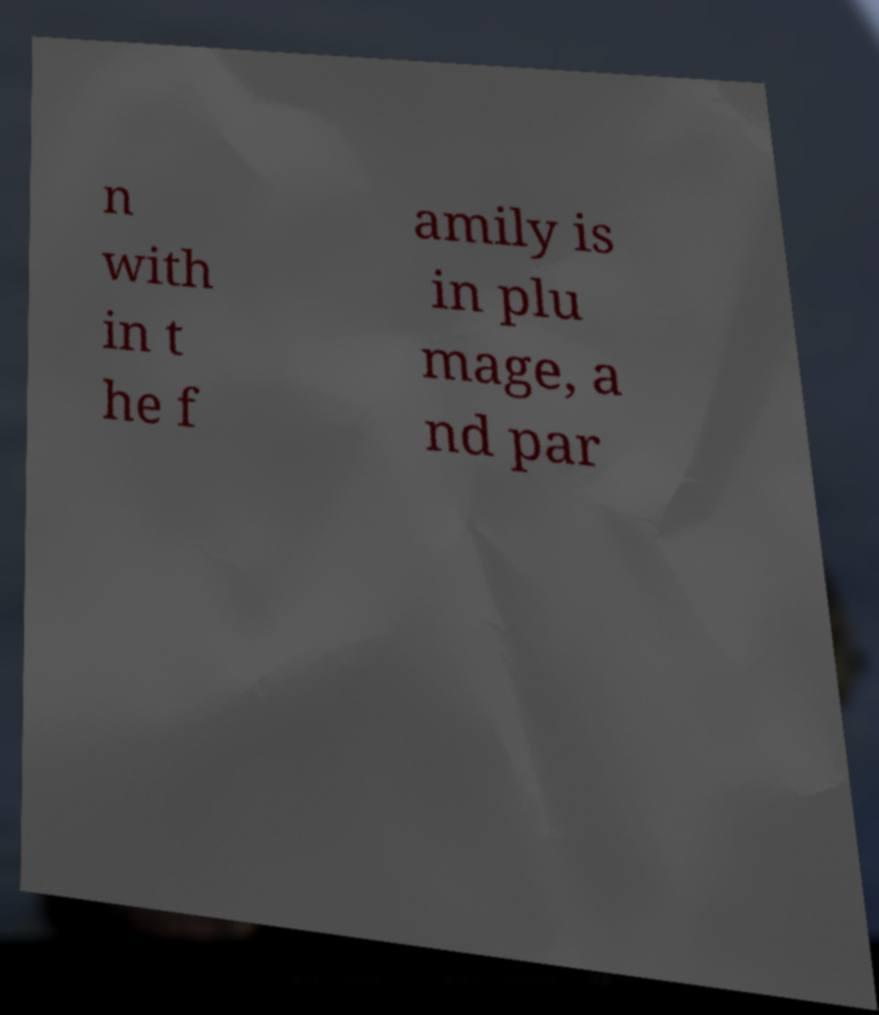For documentation purposes, I need the text within this image transcribed. Could you provide that? n with in t he f amily is in plu mage, a nd par 